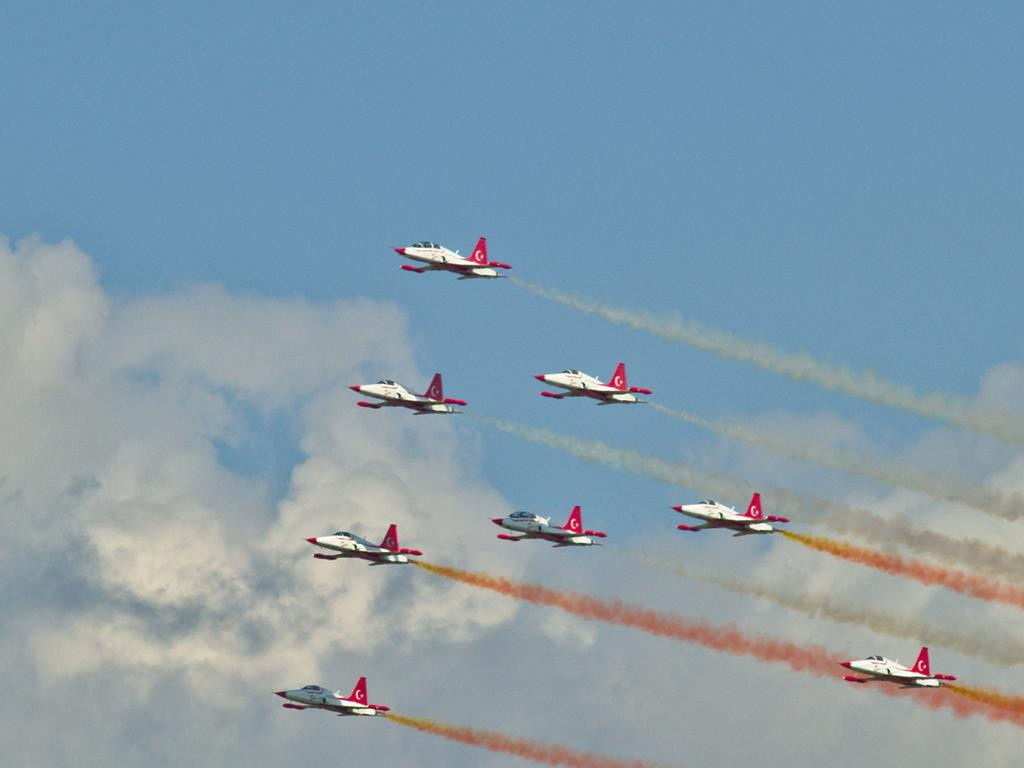What color are the aircraft in the image? The aircraft are white in color. What is happening with the aircraft in the image? The aircraft are emitting smoke and flying in the air. What can be seen in the background of the image? There are clouds in the background of the image. What is the color of the sky in the image? The sky is blue in the image. Where are the kittens sitting on the sofa in the image? There are no kittens or sofa present in the image; it features white color aircraft flying in the air. 